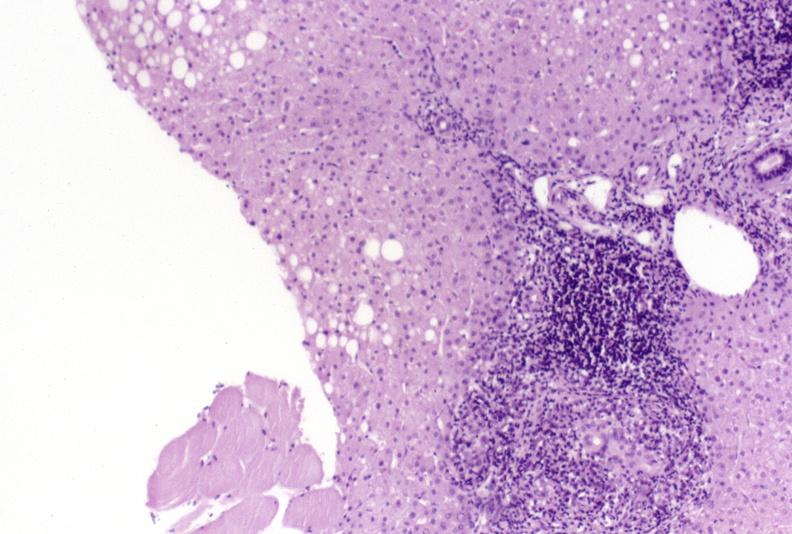s liver present?
Answer the question using a single word or phrase. Yes 